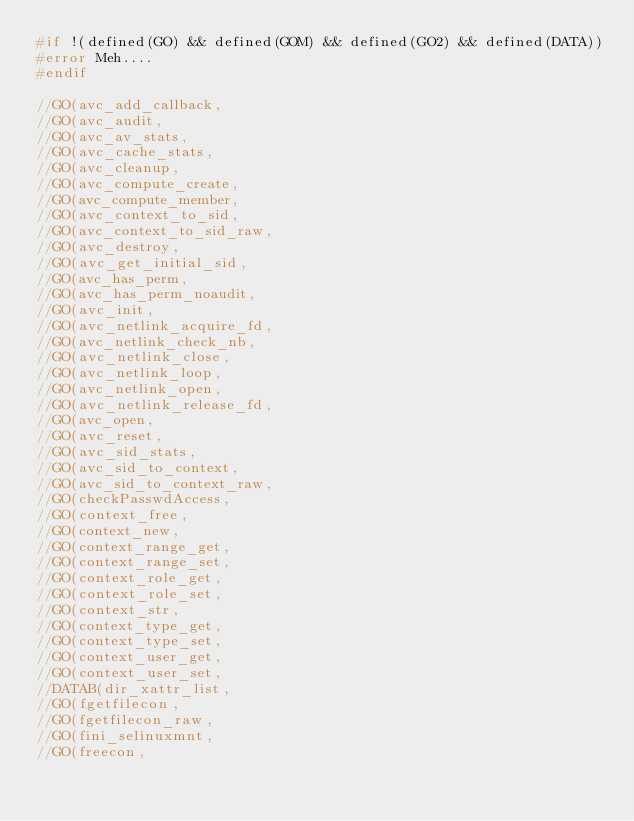Convert code to text. <code><loc_0><loc_0><loc_500><loc_500><_C_>#if !(defined(GO) && defined(GOM) && defined(GO2) && defined(DATA))
#error Meh....
#endif

//GO(avc_add_callback, 
//GO(avc_audit, 
//GO(avc_av_stats, 
//GO(avc_cache_stats, 
//GO(avc_cleanup, 
//GO(avc_compute_create, 
//GO(avc_compute_member, 
//GO(avc_context_to_sid, 
//GO(avc_context_to_sid_raw, 
//GO(avc_destroy, 
//GO(avc_get_initial_sid, 
//GO(avc_has_perm, 
//GO(avc_has_perm_noaudit, 
//GO(avc_init, 
//GO(avc_netlink_acquire_fd, 
//GO(avc_netlink_check_nb, 
//GO(avc_netlink_close, 
//GO(avc_netlink_loop, 
//GO(avc_netlink_open, 
//GO(avc_netlink_release_fd, 
//GO(avc_open, 
//GO(avc_reset, 
//GO(avc_sid_stats, 
//GO(avc_sid_to_context, 
//GO(avc_sid_to_context_raw, 
//GO(checkPasswdAccess, 
//GO(context_free, 
//GO(context_new, 
//GO(context_range_get, 
//GO(context_range_set, 
//GO(context_role_get, 
//GO(context_role_set, 
//GO(context_str, 
//GO(context_type_get, 
//GO(context_type_set, 
//GO(context_user_get, 
//GO(context_user_set, 
//DATAB(dir_xattr_list, 
//GO(fgetfilecon, 
//GO(fgetfilecon_raw, 
//GO(fini_selinuxmnt, 
//GO(freecon, </code> 